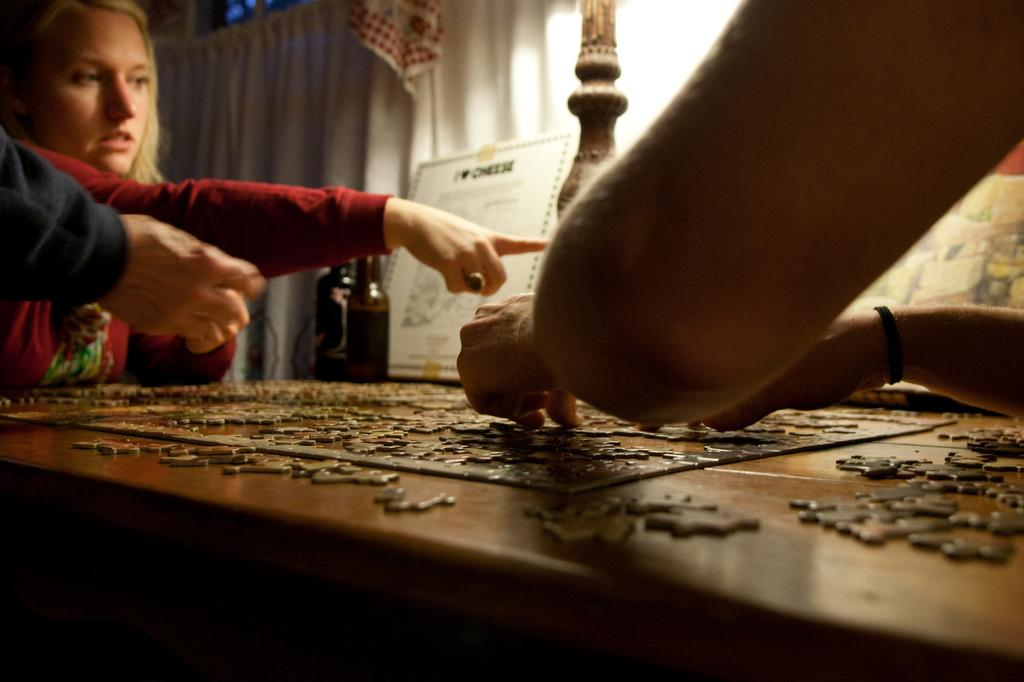How many people are in the image? There are three persons in the image. What is located beneath the persons? There is a table below the persons. What activity might the persons be engaged in, based on the presence of the puzzle game? The persons might be engaged in a puzzle-solving activity. What can be seen in the background of the image? There is a curtain in the background of the image. What type of art can be seen on the wall in the image? There is no wall or art present in the image; it features a table with a puzzle game and a curtain in the background. 